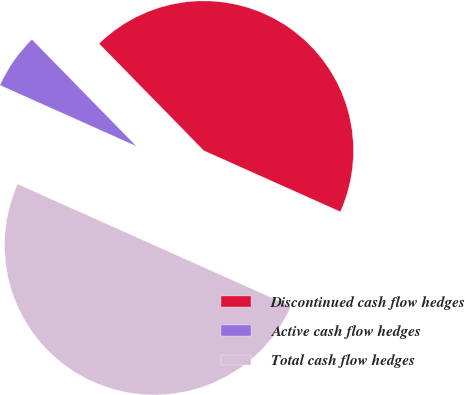Convert chart to OTSL. <chart><loc_0><loc_0><loc_500><loc_500><pie_chart><fcel>Discontinued cash flow hedges<fcel>Active cash flow hedges<fcel>Total cash flow hedges<nl><fcel>44.02%<fcel>5.98%<fcel>50.0%<nl></chart> 